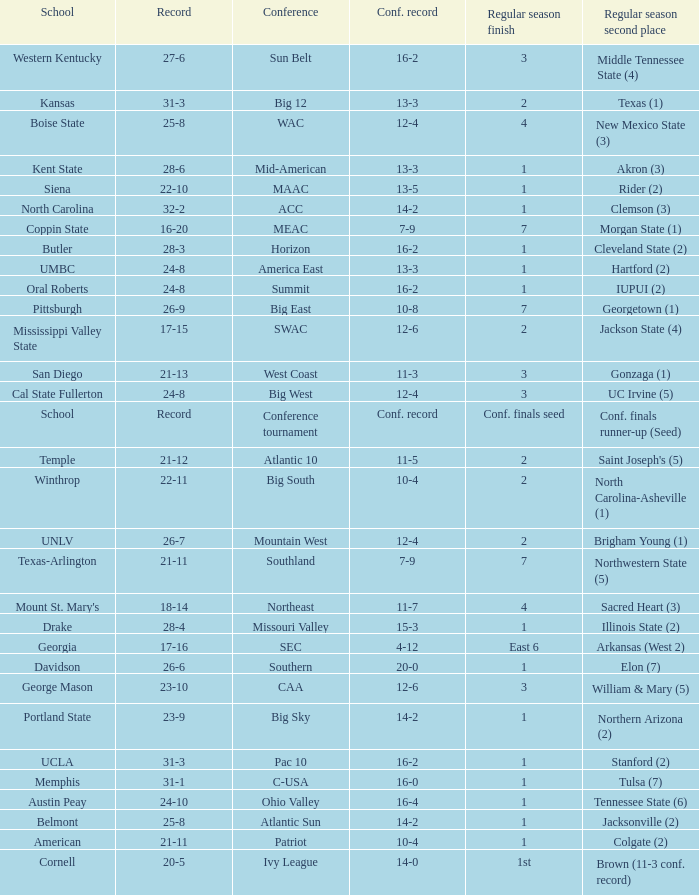What was the overall record of Oral Roberts college? 24-8. 